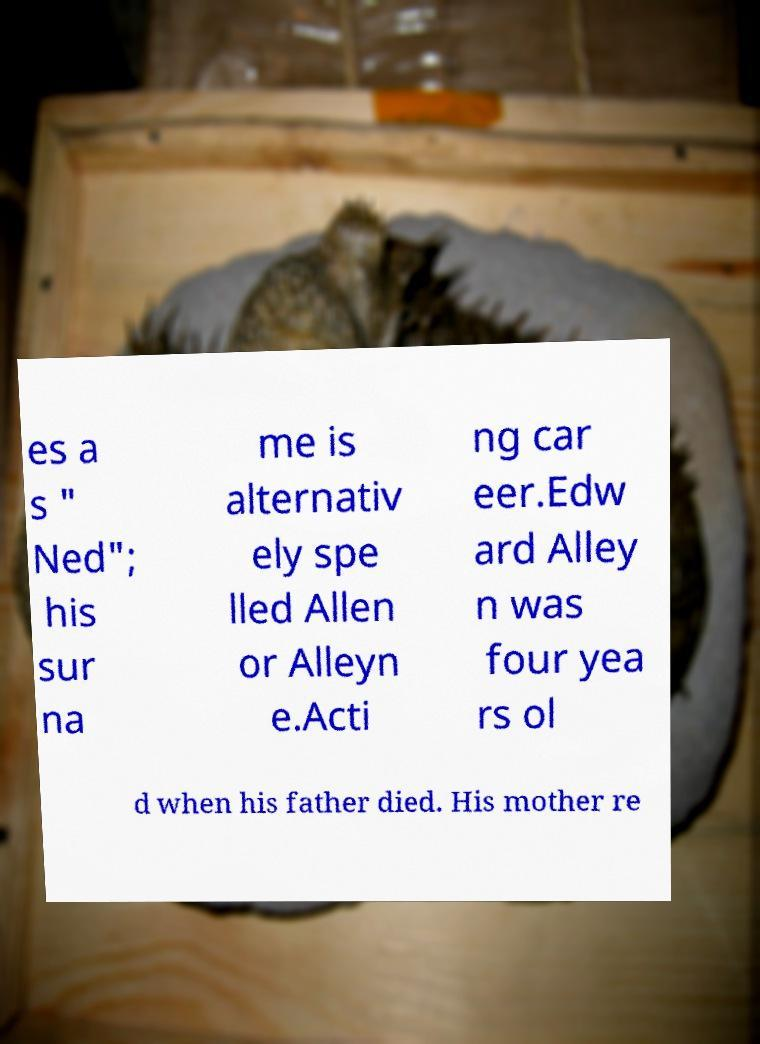Can you accurately transcribe the text from the provided image for me? es a s " Ned"; his sur na me is alternativ ely spe lled Allen or Alleyn e.Acti ng car eer.Edw ard Alley n was four yea rs ol d when his father died. His mother re 